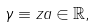<formula> <loc_0><loc_0><loc_500><loc_500>\gamma \equiv z a \in \mathbb { R } ,</formula> 